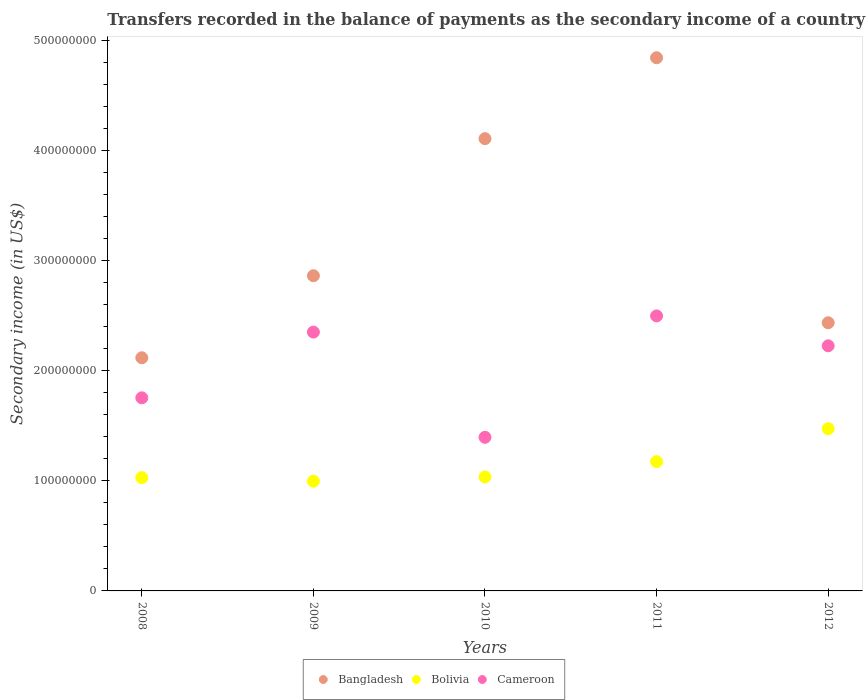Is the number of dotlines equal to the number of legend labels?
Your answer should be very brief. Yes. What is the secondary income of in Bangladesh in 2011?
Keep it short and to the point. 4.84e+08. Across all years, what is the maximum secondary income of in Bolivia?
Your response must be concise. 1.47e+08. Across all years, what is the minimum secondary income of in Cameroon?
Your answer should be very brief. 1.40e+08. In which year was the secondary income of in Cameroon maximum?
Your answer should be compact. 2011. What is the total secondary income of in Cameroon in the graph?
Make the answer very short. 1.02e+09. What is the difference between the secondary income of in Bangladesh in 2008 and that in 2011?
Make the answer very short. -2.73e+08. What is the difference between the secondary income of in Bolivia in 2011 and the secondary income of in Cameroon in 2010?
Provide a succinct answer. -2.21e+07. What is the average secondary income of in Cameroon per year?
Offer a terse response. 2.05e+08. In the year 2010, what is the difference between the secondary income of in Bolivia and secondary income of in Cameroon?
Your answer should be very brief. -3.60e+07. In how many years, is the secondary income of in Bangladesh greater than 40000000 US$?
Keep it short and to the point. 5. What is the ratio of the secondary income of in Cameroon in 2009 to that in 2011?
Ensure brevity in your answer.  0.94. What is the difference between the highest and the second highest secondary income of in Bangladesh?
Your response must be concise. 7.35e+07. What is the difference between the highest and the lowest secondary income of in Bangladesh?
Your answer should be very brief. 2.73e+08. Is the secondary income of in Cameroon strictly greater than the secondary income of in Bangladesh over the years?
Your answer should be very brief. No. Is the secondary income of in Bangladesh strictly less than the secondary income of in Bolivia over the years?
Your response must be concise. No. How many dotlines are there?
Keep it short and to the point. 3. How many years are there in the graph?
Your answer should be very brief. 5. What is the difference between two consecutive major ticks on the Y-axis?
Give a very brief answer. 1.00e+08. Are the values on the major ticks of Y-axis written in scientific E-notation?
Offer a very short reply. No. Does the graph contain any zero values?
Your answer should be very brief. No. Does the graph contain grids?
Offer a very short reply. No. Where does the legend appear in the graph?
Offer a very short reply. Bottom center. How many legend labels are there?
Offer a terse response. 3. What is the title of the graph?
Make the answer very short. Transfers recorded in the balance of payments as the secondary income of a country. Does "Qatar" appear as one of the legend labels in the graph?
Keep it short and to the point. No. What is the label or title of the Y-axis?
Provide a succinct answer. Secondary income (in US$). What is the Secondary income (in US$) of Bangladesh in 2008?
Offer a very short reply. 2.12e+08. What is the Secondary income (in US$) in Bolivia in 2008?
Your response must be concise. 1.03e+08. What is the Secondary income (in US$) of Cameroon in 2008?
Your answer should be very brief. 1.75e+08. What is the Secondary income (in US$) in Bangladesh in 2009?
Ensure brevity in your answer.  2.86e+08. What is the Secondary income (in US$) in Bolivia in 2009?
Keep it short and to the point. 9.97e+07. What is the Secondary income (in US$) in Cameroon in 2009?
Give a very brief answer. 2.35e+08. What is the Secondary income (in US$) of Bangladesh in 2010?
Your response must be concise. 4.11e+08. What is the Secondary income (in US$) in Bolivia in 2010?
Provide a short and direct response. 1.04e+08. What is the Secondary income (in US$) of Cameroon in 2010?
Keep it short and to the point. 1.40e+08. What is the Secondary income (in US$) in Bangladesh in 2011?
Your answer should be very brief. 4.84e+08. What is the Secondary income (in US$) in Bolivia in 2011?
Your response must be concise. 1.17e+08. What is the Secondary income (in US$) in Cameroon in 2011?
Your answer should be compact. 2.50e+08. What is the Secondary income (in US$) of Bangladesh in 2012?
Give a very brief answer. 2.44e+08. What is the Secondary income (in US$) of Bolivia in 2012?
Your answer should be compact. 1.47e+08. What is the Secondary income (in US$) of Cameroon in 2012?
Your answer should be very brief. 2.23e+08. Across all years, what is the maximum Secondary income (in US$) of Bangladesh?
Provide a short and direct response. 4.84e+08. Across all years, what is the maximum Secondary income (in US$) in Bolivia?
Provide a succinct answer. 1.47e+08. Across all years, what is the maximum Secondary income (in US$) of Cameroon?
Your answer should be very brief. 2.50e+08. Across all years, what is the minimum Secondary income (in US$) of Bangladesh?
Provide a short and direct response. 2.12e+08. Across all years, what is the minimum Secondary income (in US$) of Bolivia?
Provide a succinct answer. 9.97e+07. Across all years, what is the minimum Secondary income (in US$) of Cameroon?
Ensure brevity in your answer.  1.40e+08. What is the total Secondary income (in US$) in Bangladesh in the graph?
Your answer should be compact. 1.64e+09. What is the total Secondary income (in US$) of Bolivia in the graph?
Give a very brief answer. 5.71e+08. What is the total Secondary income (in US$) in Cameroon in the graph?
Provide a succinct answer. 1.02e+09. What is the difference between the Secondary income (in US$) in Bangladesh in 2008 and that in 2009?
Give a very brief answer. -7.45e+07. What is the difference between the Secondary income (in US$) of Bolivia in 2008 and that in 2009?
Make the answer very short. 3.17e+06. What is the difference between the Secondary income (in US$) of Cameroon in 2008 and that in 2009?
Ensure brevity in your answer.  -5.97e+07. What is the difference between the Secondary income (in US$) in Bangladesh in 2008 and that in 2010?
Your response must be concise. -1.99e+08. What is the difference between the Secondary income (in US$) in Bolivia in 2008 and that in 2010?
Your response must be concise. -6.43e+05. What is the difference between the Secondary income (in US$) of Cameroon in 2008 and that in 2010?
Provide a short and direct response. 3.59e+07. What is the difference between the Secondary income (in US$) in Bangladesh in 2008 and that in 2011?
Provide a succinct answer. -2.73e+08. What is the difference between the Secondary income (in US$) in Bolivia in 2008 and that in 2011?
Provide a short and direct response. -1.45e+07. What is the difference between the Secondary income (in US$) of Cameroon in 2008 and that in 2011?
Ensure brevity in your answer.  -7.44e+07. What is the difference between the Secondary income (in US$) in Bangladesh in 2008 and that in 2012?
Provide a succinct answer. -3.18e+07. What is the difference between the Secondary income (in US$) in Bolivia in 2008 and that in 2012?
Provide a succinct answer. -4.45e+07. What is the difference between the Secondary income (in US$) of Cameroon in 2008 and that in 2012?
Your response must be concise. -4.72e+07. What is the difference between the Secondary income (in US$) of Bangladesh in 2009 and that in 2010?
Ensure brevity in your answer.  -1.25e+08. What is the difference between the Secondary income (in US$) in Bolivia in 2009 and that in 2010?
Offer a terse response. -3.81e+06. What is the difference between the Secondary income (in US$) in Cameroon in 2009 and that in 2010?
Offer a very short reply. 9.56e+07. What is the difference between the Secondary income (in US$) in Bangladesh in 2009 and that in 2011?
Ensure brevity in your answer.  -1.98e+08. What is the difference between the Secondary income (in US$) of Bolivia in 2009 and that in 2011?
Provide a short and direct response. -1.77e+07. What is the difference between the Secondary income (in US$) in Cameroon in 2009 and that in 2011?
Your answer should be compact. -1.47e+07. What is the difference between the Secondary income (in US$) of Bangladesh in 2009 and that in 2012?
Offer a terse response. 4.27e+07. What is the difference between the Secondary income (in US$) in Bolivia in 2009 and that in 2012?
Your answer should be very brief. -4.76e+07. What is the difference between the Secondary income (in US$) in Cameroon in 2009 and that in 2012?
Offer a terse response. 1.25e+07. What is the difference between the Secondary income (in US$) of Bangladesh in 2010 and that in 2011?
Provide a succinct answer. -7.35e+07. What is the difference between the Secondary income (in US$) in Bolivia in 2010 and that in 2011?
Offer a terse response. -1.39e+07. What is the difference between the Secondary income (in US$) of Cameroon in 2010 and that in 2011?
Your response must be concise. -1.10e+08. What is the difference between the Secondary income (in US$) in Bangladesh in 2010 and that in 2012?
Provide a succinct answer. 1.67e+08. What is the difference between the Secondary income (in US$) of Bolivia in 2010 and that in 2012?
Give a very brief answer. -4.38e+07. What is the difference between the Secondary income (in US$) in Cameroon in 2010 and that in 2012?
Ensure brevity in your answer.  -8.31e+07. What is the difference between the Secondary income (in US$) of Bangladesh in 2011 and that in 2012?
Make the answer very short. 2.41e+08. What is the difference between the Secondary income (in US$) of Bolivia in 2011 and that in 2012?
Provide a short and direct response. -2.99e+07. What is the difference between the Secondary income (in US$) in Cameroon in 2011 and that in 2012?
Your answer should be very brief. 2.71e+07. What is the difference between the Secondary income (in US$) of Bangladesh in 2008 and the Secondary income (in US$) of Bolivia in 2009?
Your answer should be compact. 1.12e+08. What is the difference between the Secondary income (in US$) in Bangladesh in 2008 and the Secondary income (in US$) in Cameroon in 2009?
Provide a succinct answer. -2.33e+07. What is the difference between the Secondary income (in US$) in Bolivia in 2008 and the Secondary income (in US$) in Cameroon in 2009?
Your response must be concise. -1.32e+08. What is the difference between the Secondary income (in US$) of Bangladesh in 2008 and the Secondary income (in US$) of Bolivia in 2010?
Offer a terse response. 1.08e+08. What is the difference between the Secondary income (in US$) of Bangladesh in 2008 and the Secondary income (in US$) of Cameroon in 2010?
Offer a very short reply. 7.22e+07. What is the difference between the Secondary income (in US$) in Bolivia in 2008 and the Secondary income (in US$) in Cameroon in 2010?
Ensure brevity in your answer.  -3.67e+07. What is the difference between the Secondary income (in US$) in Bangladesh in 2008 and the Secondary income (in US$) in Bolivia in 2011?
Your response must be concise. 9.44e+07. What is the difference between the Secondary income (in US$) of Bangladesh in 2008 and the Secondary income (in US$) of Cameroon in 2011?
Ensure brevity in your answer.  -3.80e+07. What is the difference between the Secondary income (in US$) in Bolivia in 2008 and the Secondary income (in US$) in Cameroon in 2011?
Ensure brevity in your answer.  -1.47e+08. What is the difference between the Secondary income (in US$) of Bangladesh in 2008 and the Secondary income (in US$) of Bolivia in 2012?
Give a very brief answer. 6.44e+07. What is the difference between the Secondary income (in US$) in Bangladesh in 2008 and the Secondary income (in US$) in Cameroon in 2012?
Give a very brief answer. -1.09e+07. What is the difference between the Secondary income (in US$) of Bolivia in 2008 and the Secondary income (in US$) of Cameroon in 2012?
Your response must be concise. -1.20e+08. What is the difference between the Secondary income (in US$) of Bangladesh in 2009 and the Secondary income (in US$) of Bolivia in 2010?
Make the answer very short. 1.83e+08. What is the difference between the Secondary income (in US$) of Bangladesh in 2009 and the Secondary income (in US$) of Cameroon in 2010?
Keep it short and to the point. 1.47e+08. What is the difference between the Secondary income (in US$) of Bolivia in 2009 and the Secondary income (in US$) of Cameroon in 2010?
Ensure brevity in your answer.  -3.98e+07. What is the difference between the Secondary income (in US$) in Bangladesh in 2009 and the Secondary income (in US$) in Bolivia in 2011?
Make the answer very short. 1.69e+08. What is the difference between the Secondary income (in US$) in Bangladesh in 2009 and the Secondary income (in US$) in Cameroon in 2011?
Ensure brevity in your answer.  3.65e+07. What is the difference between the Secondary income (in US$) of Bolivia in 2009 and the Secondary income (in US$) of Cameroon in 2011?
Your answer should be compact. -1.50e+08. What is the difference between the Secondary income (in US$) of Bangladesh in 2009 and the Secondary income (in US$) of Bolivia in 2012?
Make the answer very short. 1.39e+08. What is the difference between the Secondary income (in US$) of Bangladesh in 2009 and the Secondary income (in US$) of Cameroon in 2012?
Keep it short and to the point. 6.36e+07. What is the difference between the Secondary income (in US$) of Bolivia in 2009 and the Secondary income (in US$) of Cameroon in 2012?
Keep it short and to the point. -1.23e+08. What is the difference between the Secondary income (in US$) in Bangladesh in 2010 and the Secondary income (in US$) in Bolivia in 2011?
Ensure brevity in your answer.  2.93e+08. What is the difference between the Secondary income (in US$) of Bangladesh in 2010 and the Secondary income (in US$) of Cameroon in 2011?
Give a very brief answer. 1.61e+08. What is the difference between the Secondary income (in US$) in Bolivia in 2010 and the Secondary income (in US$) in Cameroon in 2011?
Offer a very short reply. -1.46e+08. What is the difference between the Secondary income (in US$) of Bangladesh in 2010 and the Secondary income (in US$) of Bolivia in 2012?
Your answer should be compact. 2.63e+08. What is the difference between the Secondary income (in US$) of Bangladesh in 2010 and the Secondary income (in US$) of Cameroon in 2012?
Make the answer very short. 1.88e+08. What is the difference between the Secondary income (in US$) of Bolivia in 2010 and the Secondary income (in US$) of Cameroon in 2012?
Give a very brief answer. -1.19e+08. What is the difference between the Secondary income (in US$) in Bangladesh in 2011 and the Secondary income (in US$) in Bolivia in 2012?
Your answer should be very brief. 3.37e+08. What is the difference between the Secondary income (in US$) of Bangladesh in 2011 and the Secondary income (in US$) of Cameroon in 2012?
Provide a short and direct response. 2.62e+08. What is the difference between the Secondary income (in US$) of Bolivia in 2011 and the Secondary income (in US$) of Cameroon in 2012?
Your answer should be very brief. -1.05e+08. What is the average Secondary income (in US$) in Bangladesh per year?
Offer a very short reply. 3.27e+08. What is the average Secondary income (in US$) of Bolivia per year?
Provide a succinct answer. 1.14e+08. What is the average Secondary income (in US$) in Cameroon per year?
Provide a short and direct response. 2.05e+08. In the year 2008, what is the difference between the Secondary income (in US$) of Bangladesh and Secondary income (in US$) of Bolivia?
Your answer should be compact. 1.09e+08. In the year 2008, what is the difference between the Secondary income (in US$) of Bangladesh and Secondary income (in US$) of Cameroon?
Offer a very short reply. 3.64e+07. In the year 2008, what is the difference between the Secondary income (in US$) of Bolivia and Secondary income (in US$) of Cameroon?
Your answer should be compact. -7.25e+07. In the year 2009, what is the difference between the Secondary income (in US$) in Bangladesh and Secondary income (in US$) in Bolivia?
Offer a terse response. 1.87e+08. In the year 2009, what is the difference between the Secondary income (in US$) in Bangladesh and Secondary income (in US$) in Cameroon?
Provide a short and direct response. 5.12e+07. In the year 2009, what is the difference between the Secondary income (in US$) of Bolivia and Secondary income (in US$) of Cameroon?
Provide a short and direct response. -1.35e+08. In the year 2010, what is the difference between the Secondary income (in US$) of Bangladesh and Secondary income (in US$) of Bolivia?
Your answer should be compact. 3.07e+08. In the year 2010, what is the difference between the Secondary income (in US$) in Bangladesh and Secondary income (in US$) in Cameroon?
Provide a succinct answer. 2.71e+08. In the year 2010, what is the difference between the Secondary income (in US$) in Bolivia and Secondary income (in US$) in Cameroon?
Offer a terse response. -3.60e+07. In the year 2011, what is the difference between the Secondary income (in US$) in Bangladesh and Secondary income (in US$) in Bolivia?
Your answer should be compact. 3.67e+08. In the year 2011, what is the difference between the Secondary income (in US$) in Bangladesh and Secondary income (in US$) in Cameroon?
Your answer should be very brief. 2.35e+08. In the year 2011, what is the difference between the Secondary income (in US$) of Bolivia and Secondary income (in US$) of Cameroon?
Make the answer very short. -1.32e+08. In the year 2012, what is the difference between the Secondary income (in US$) of Bangladesh and Secondary income (in US$) of Bolivia?
Provide a succinct answer. 9.62e+07. In the year 2012, what is the difference between the Secondary income (in US$) of Bangladesh and Secondary income (in US$) of Cameroon?
Provide a short and direct response. 2.09e+07. In the year 2012, what is the difference between the Secondary income (in US$) of Bolivia and Secondary income (in US$) of Cameroon?
Your response must be concise. -7.53e+07. What is the ratio of the Secondary income (in US$) of Bangladesh in 2008 to that in 2009?
Ensure brevity in your answer.  0.74. What is the ratio of the Secondary income (in US$) in Bolivia in 2008 to that in 2009?
Keep it short and to the point. 1.03. What is the ratio of the Secondary income (in US$) in Cameroon in 2008 to that in 2009?
Make the answer very short. 0.75. What is the ratio of the Secondary income (in US$) in Bangladesh in 2008 to that in 2010?
Ensure brevity in your answer.  0.52. What is the ratio of the Secondary income (in US$) of Bolivia in 2008 to that in 2010?
Offer a terse response. 0.99. What is the ratio of the Secondary income (in US$) of Cameroon in 2008 to that in 2010?
Your answer should be compact. 1.26. What is the ratio of the Secondary income (in US$) in Bangladesh in 2008 to that in 2011?
Your response must be concise. 0.44. What is the ratio of the Secondary income (in US$) of Bolivia in 2008 to that in 2011?
Your answer should be very brief. 0.88. What is the ratio of the Secondary income (in US$) of Cameroon in 2008 to that in 2011?
Provide a succinct answer. 0.7. What is the ratio of the Secondary income (in US$) in Bangladesh in 2008 to that in 2012?
Keep it short and to the point. 0.87. What is the ratio of the Secondary income (in US$) in Bolivia in 2008 to that in 2012?
Ensure brevity in your answer.  0.7. What is the ratio of the Secondary income (in US$) in Cameroon in 2008 to that in 2012?
Provide a short and direct response. 0.79. What is the ratio of the Secondary income (in US$) in Bangladesh in 2009 to that in 2010?
Offer a very short reply. 0.7. What is the ratio of the Secondary income (in US$) in Bolivia in 2009 to that in 2010?
Make the answer very short. 0.96. What is the ratio of the Secondary income (in US$) in Cameroon in 2009 to that in 2010?
Your answer should be very brief. 1.68. What is the ratio of the Secondary income (in US$) of Bangladesh in 2009 to that in 2011?
Your response must be concise. 0.59. What is the ratio of the Secondary income (in US$) in Bolivia in 2009 to that in 2011?
Offer a terse response. 0.85. What is the ratio of the Secondary income (in US$) of Cameroon in 2009 to that in 2011?
Provide a short and direct response. 0.94. What is the ratio of the Secondary income (in US$) in Bangladesh in 2009 to that in 2012?
Keep it short and to the point. 1.18. What is the ratio of the Secondary income (in US$) in Bolivia in 2009 to that in 2012?
Give a very brief answer. 0.68. What is the ratio of the Secondary income (in US$) in Cameroon in 2009 to that in 2012?
Make the answer very short. 1.06. What is the ratio of the Secondary income (in US$) in Bangladesh in 2010 to that in 2011?
Make the answer very short. 0.85. What is the ratio of the Secondary income (in US$) in Bolivia in 2010 to that in 2011?
Provide a short and direct response. 0.88. What is the ratio of the Secondary income (in US$) of Cameroon in 2010 to that in 2011?
Your response must be concise. 0.56. What is the ratio of the Secondary income (in US$) in Bangladesh in 2010 to that in 2012?
Provide a succinct answer. 1.69. What is the ratio of the Secondary income (in US$) of Bolivia in 2010 to that in 2012?
Give a very brief answer. 0.7. What is the ratio of the Secondary income (in US$) in Cameroon in 2010 to that in 2012?
Offer a very short reply. 0.63. What is the ratio of the Secondary income (in US$) in Bangladesh in 2011 to that in 2012?
Offer a very short reply. 1.99. What is the ratio of the Secondary income (in US$) of Bolivia in 2011 to that in 2012?
Offer a terse response. 0.8. What is the ratio of the Secondary income (in US$) in Cameroon in 2011 to that in 2012?
Your response must be concise. 1.12. What is the difference between the highest and the second highest Secondary income (in US$) in Bangladesh?
Ensure brevity in your answer.  7.35e+07. What is the difference between the highest and the second highest Secondary income (in US$) in Bolivia?
Your answer should be very brief. 2.99e+07. What is the difference between the highest and the second highest Secondary income (in US$) in Cameroon?
Provide a succinct answer. 1.47e+07. What is the difference between the highest and the lowest Secondary income (in US$) in Bangladesh?
Ensure brevity in your answer.  2.73e+08. What is the difference between the highest and the lowest Secondary income (in US$) of Bolivia?
Offer a very short reply. 4.76e+07. What is the difference between the highest and the lowest Secondary income (in US$) of Cameroon?
Offer a terse response. 1.10e+08. 